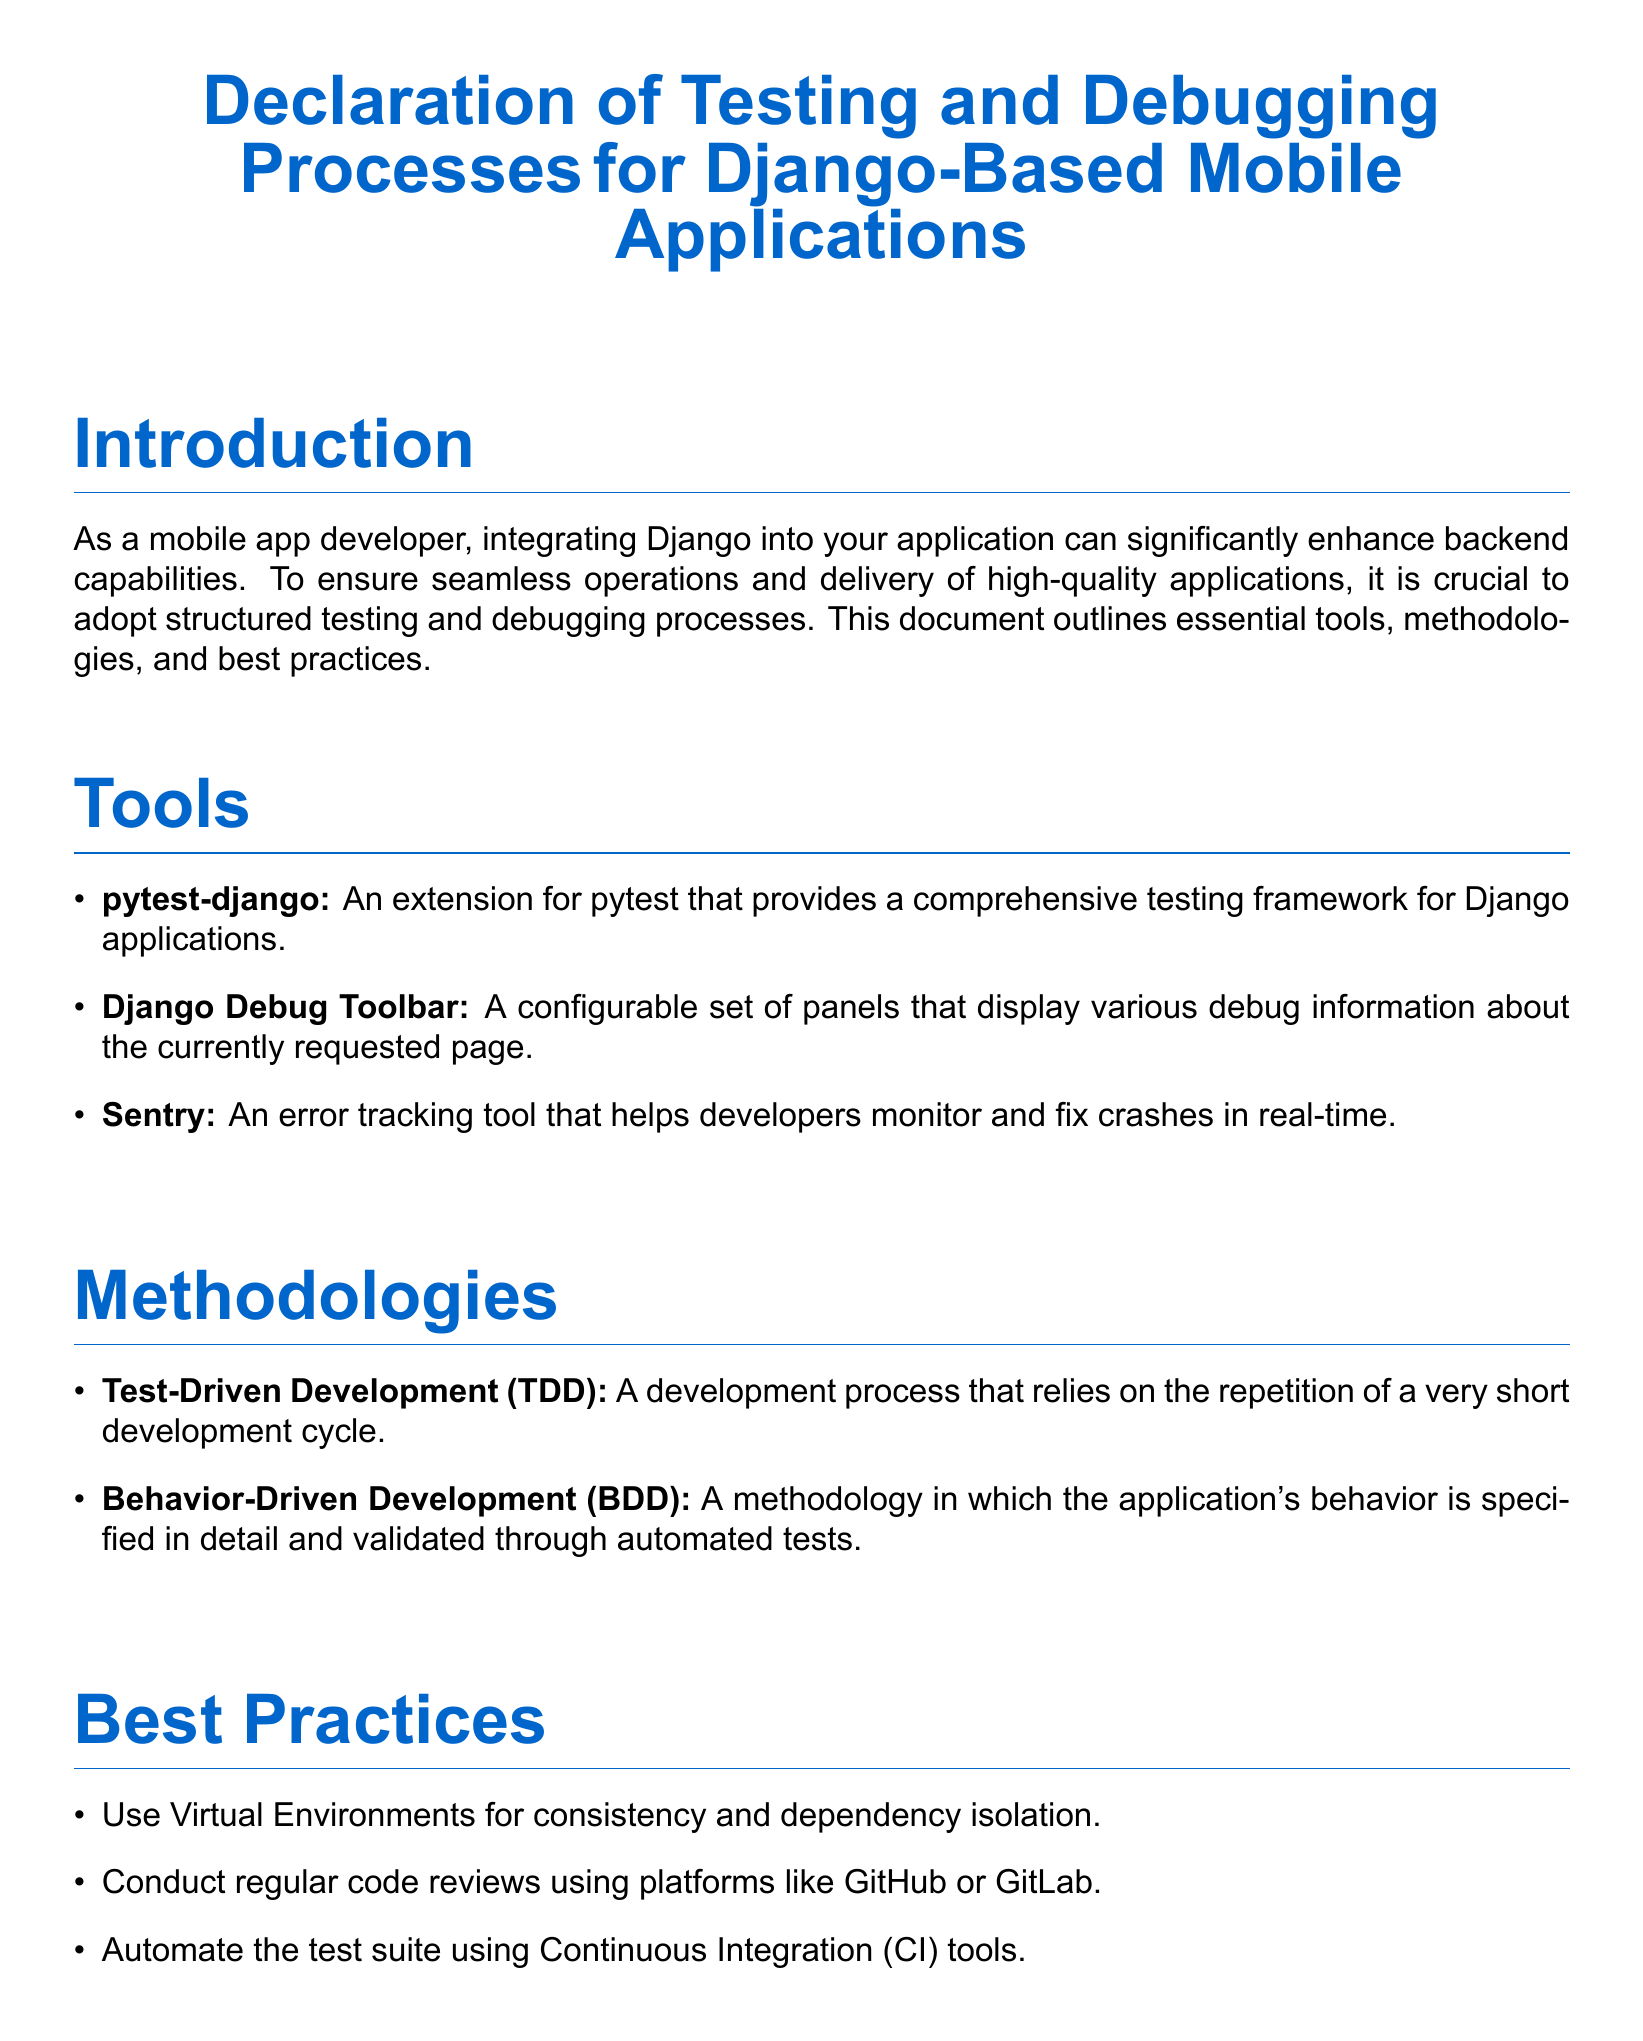What is the title of the document? The title of the document is the main heading presented in a large font at the top, which describes the purpose of the document.
Answer: Declaration of Testing and Debugging Processes for Django-Based Mobile Applications What testing framework is mentioned? The document states specific tools for testing, including a popular testing framework for Django applications.
Answer: pytest-django What methodology emphasizes validations through automated tests? The document lists methodologies and identifies one that focuses on validating application behavior via specific tests.
Answer: Behavior-Driven Development Which debugging tool is included in the document? The document outlines various tools for debugging, specifying a particular tool used to display debug information for web pages.
Answer: Django Debug Toolbar What is a suggested practice for code evaluations? The document recommends a certain approach for improving code quality through collaborative reviews.
Answer: Regular code reviews What type of environments should be used for dependency management? The document advises on specific kinds of environments to maintain consistent packages across development.
Answer: Virtual Environments How many methodologies are mentioned in the document? The methodologies section lists two distinct methodologies essential for development, which answers the inquiry of quantity.
Answer: 2 What is included in the example test case? The example test case is meant to provide a concise code snippet that shows how to test a particular view in Django.
Answer: Homepage test What is the primary goal of integrating testing and debugging in Django applications? The conclusion summarizes the overall purpose of adopting structured processes in mobile app development using Django.
Answer: Successful integration 